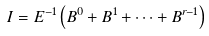Convert formula to latex. <formula><loc_0><loc_0><loc_500><loc_500>I = E ^ { - 1 } \left ( B ^ { 0 } + B ^ { 1 } + \dots + B ^ { r - 1 } \right )</formula> 